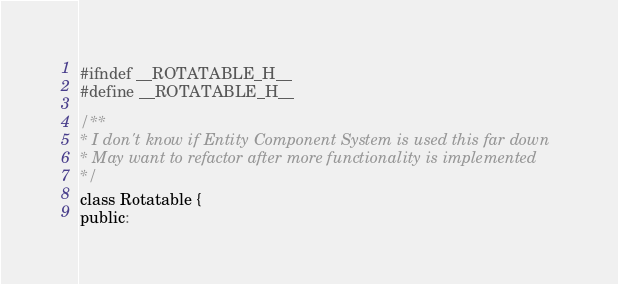<code> <loc_0><loc_0><loc_500><loc_500><_C_>#ifndef __ROTATABLE_H__
#define __ROTATABLE_H__

/**
* I don't know if Entity Component System is used this far down
* May want to refactor after more functionality is implemented
*/
class Rotatable {
public:</code> 